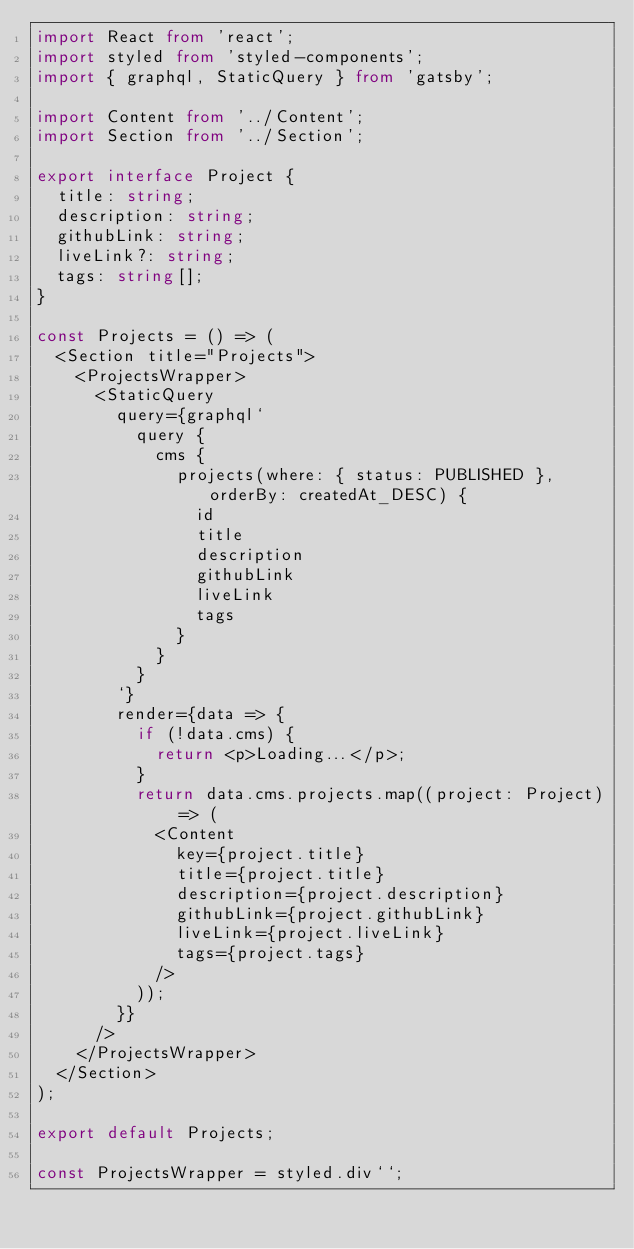Convert code to text. <code><loc_0><loc_0><loc_500><loc_500><_TypeScript_>import React from 'react';
import styled from 'styled-components';
import { graphql, StaticQuery } from 'gatsby';

import Content from '../Content';
import Section from '../Section';

export interface Project {
  title: string;
  description: string;
  githubLink: string;
  liveLink?: string;
  tags: string[];
}

const Projects = () => (
  <Section title="Projects">
    <ProjectsWrapper>
      <StaticQuery
        query={graphql`
          query {
            cms {
              projects(where: { status: PUBLISHED }, orderBy: createdAt_DESC) {
                id
                title
                description
                githubLink
                liveLink
                tags
              }
            }
          }
        `}
        render={data => {
          if (!data.cms) {
            return <p>Loading...</p>;
          }
          return data.cms.projects.map((project: Project) => (
            <Content
              key={project.title}
              title={project.title}
              description={project.description}
              githubLink={project.githubLink}
              liveLink={project.liveLink}
              tags={project.tags}
            />
          ));
        }}
      />
    </ProjectsWrapper>
  </Section>
);

export default Projects;

const ProjectsWrapper = styled.div``;
</code> 